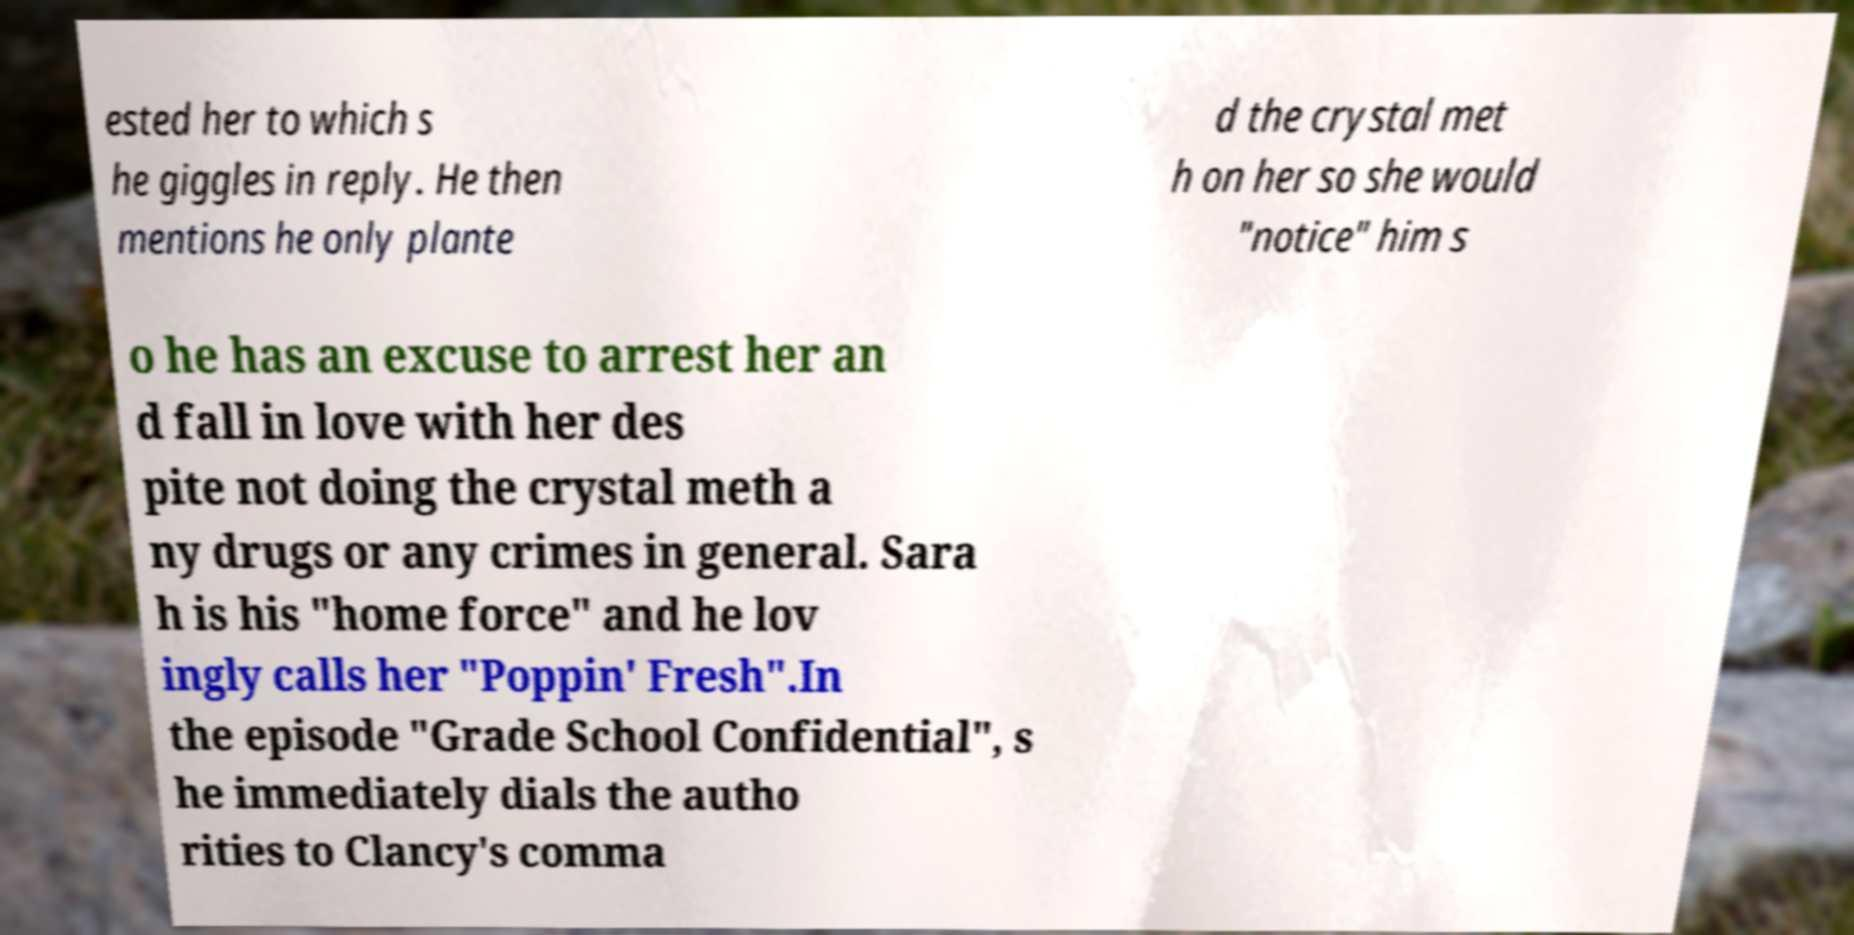Please read and relay the text visible in this image. What does it say? ested her to which s he giggles in reply. He then mentions he only plante d the crystal met h on her so she would "notice" him s o he has an excuse to arrest her an d fall in love with her des pite not doing the crystal meth a ny drugs or any crimes in general. Sara h is his "home force" and he lov ingly calls her "Poppin' Fresh".In the episode "Grade School Confidential", s he immediately dials the autho rities to Clancy's comma 